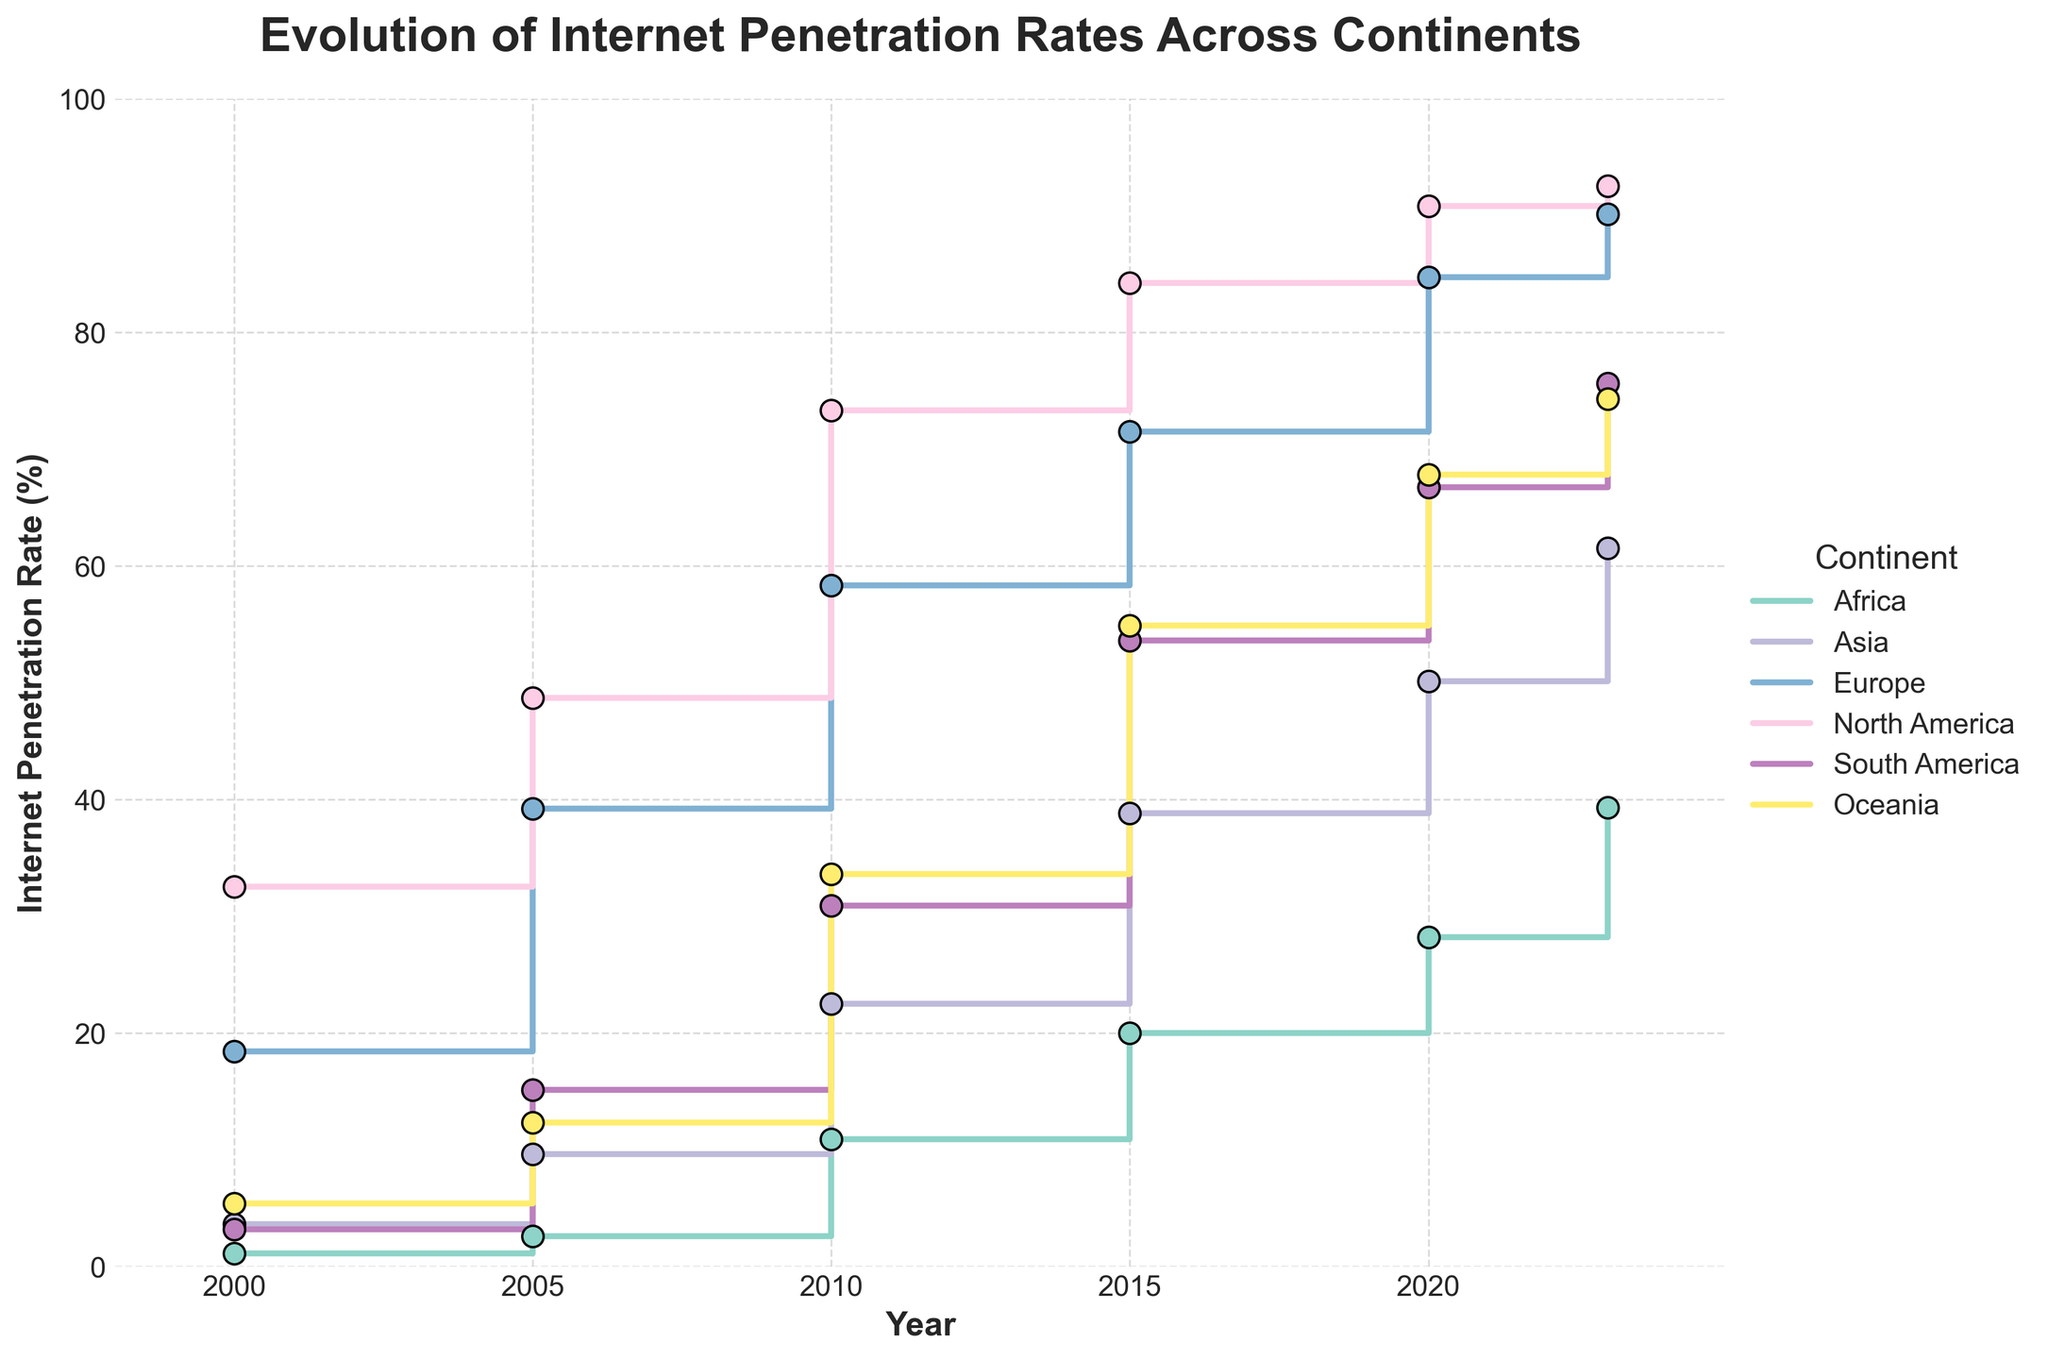What is the title of the figure? The title of the figure is prominently displayed at the top and is meant to describe the main subject of the chart. It reads, "Evolution of Internet Penetration Rates Across Continents".
Answer: Evolution of Internet Penetration Rates Across Continents What is the internet penetration rate in Africa in 2000? The internet penetration rate in Africa in 2000 is shown as one of the data points on the stair plot for Africa. According to the figure, it's 1.1%.
Answer: 1.1% Which continent had the highest internet penetration rate in 2023? To answer this, look at the end points on the stair plot corresponding to each continent in the year 2023. Europe has the highest data point at the year 2023, indicating 90.1%.
Answer: Europe By how much did the internet penetration rate in Asia increase from 2000 to 2023? Subtract the internet penetration rate of Asia in 2000 from that in 2023. From the figure, it shows 61.5% in 2023 and 3.6% in 2000. So, the difference is 61.5 - 3.6 = 57.9%.
Answer: 57.9% Which continent experienced the greatest increase in internet penetration rate between 2010 and 2015? Compare the increments for all continents between 2010 and 2015. Asia's rate increased from 22.5% to 38.8%, an increase of 16.3%, which is greater than the increases seen in other continents.
Answer: Asia What was the approximate global average internet penetration rate for the continents in 2020? Calculate the average of the 2020 internet penetration rates across all continents: (28.2 + 50.1 + 84.7 + 90.8 + 66.7 + 67.8) / 6 = 64.72%.
Answer: 64.72% Which continent showed a consistent increase in internet penetration rate over each given year without any decrease? By inspecting the stair plots for each continent, Europe consistently shows an increase from 2000 to 2023 without any decline in the internet penetration rate.
Answer: Europe In which period did North America see its biggest jump in internet penetration rate? Compare the differences for North America's data points across all intervals. The biggest jump is from 2005 (48.7%) to 2010 (73.3%), a 24.6% increase.
Answer: 2005-2010 How does the internet penetration rate in South America in 2023 compare to Oceania in 2023? Look at the end points for both South America and Oceania in 2023. South America's rate is 75.6%, while Oceania's is 74.3%, so South America is higher by 1.3%.
Answer: South America is higher Which continent had the lowest rate in 2000, and how much has it increased by 2023? Find the lowest rate in 2000 and track its increment to 2023. Africa had the lowest rate in 2000 at 1.1%, increasing to 39.3% in 2023, an increase of 38.2%.
Answer: Africa, 38.2% 